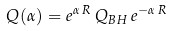<formula> <loc_0><loc_0><loc_500><loc_500>Q ( \alpha ) = e ^ { \alpha \, R } \, Q _ { B H } \, e ^ { - \alpha \, R }</formula> 